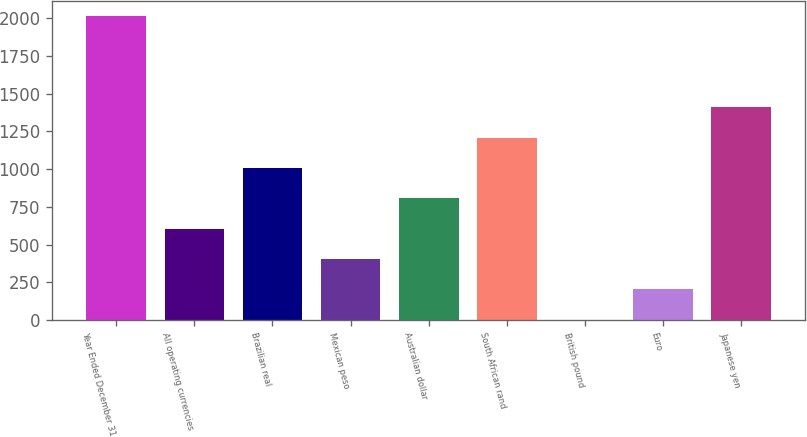Convert chart. <chart><loc_0><loc_0><loc_500><loc_500><bar_chart><fcel>Year Ended December 31<fcel>All operating currencies<fcel>Brazilian real<fcel>Mexican peso<fcel>Australian dollar<fcel>South African rand<fcel>British pound<fcel>Euro<fcel>Japanese yen<nl><fcel>2013<fcel>605.3<fcel>1007.5<fcel>404.2<fcel>806.4<fcel>1208.6<fcel>2<fcel>203.1<fcel>1409.7<nl></chart> 